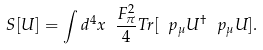<formula> <loc_0><loc_0><loc_500><loc_500>S [ U ] = \int d ^ { 4 } x \ \frac { F _ { \pi } ^ { 2 } } { 4 } T r [ \ p _ { \mu } U ^ { \dagger } \ p _ { \mu } U ] .</formula> 